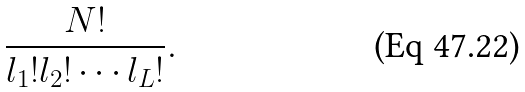<formula> <loc_0><loc_0><loc_500><loc_500>\frac { N ! } { l _ { 1 } ! l _ { 2 } ! \cdots l _ { L } ! } .</formula> 